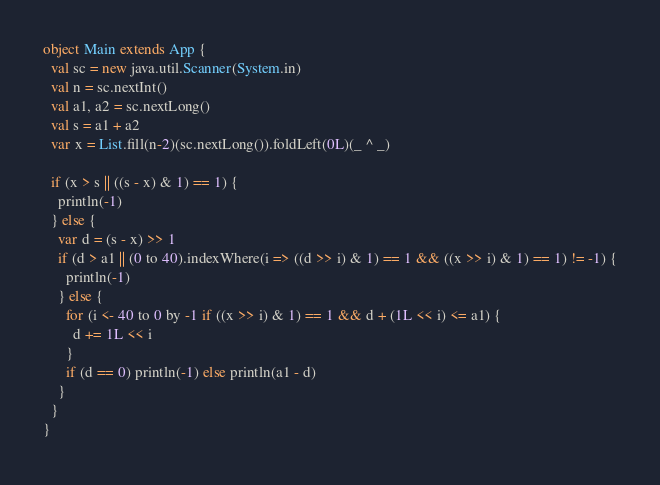<code> <loc_0><loc_0><loc_500><loc_500><_Scala_>object Main extends App {
  val sc = new java.util.Scanner(System.in)
  val n = sc.nextInt()
  val a1, a2 = sc.nextLong()
  val s = a1 + a2
  var x = List.fill(n-2)(sc.nextLong()).foldLeft(0L)(_ ^ _)

  if (x > s || ((s - x) & 1) == 1) {
    println(-1)
  } else {
    var d = (s - x) >> 1
    if (d > a1 || (0 to 40).indexWhere(i => ((d >> i) & 1) == 1 && ((x >> i) & 1) == 1) != -1) {
      println(-1)
    } else {
      for (i <- 40 to 0 by -1 if ((x >> i) & 1) == 1 && d + (1L << i) <= a1) {
        d += 1L << i
      }
      if (d == 0) println(-1) else println(a1 - d)
    }
  }
}
</code> 